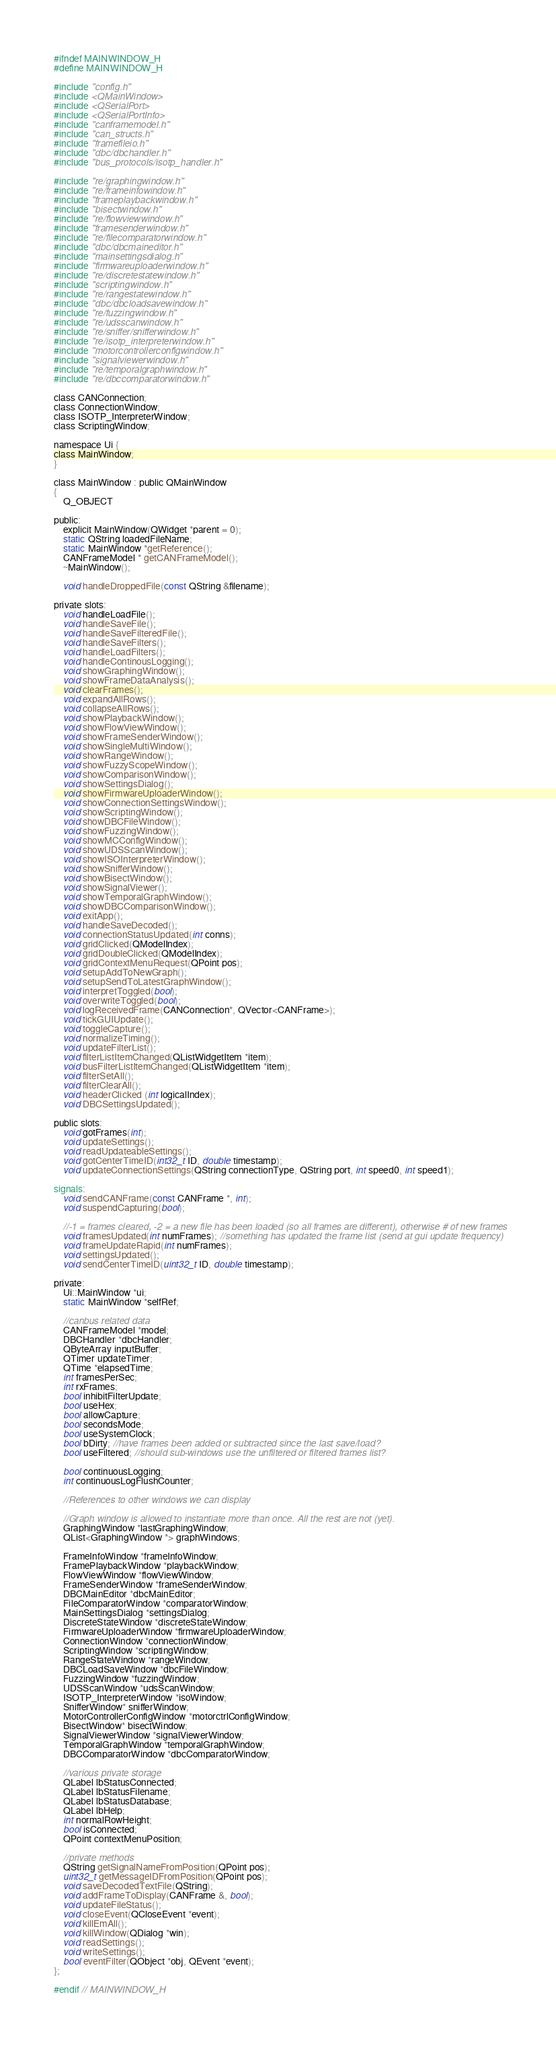<code> <loc_0><loc_0><loc_500><loc_500><_C_>#ifndef MAINWINDOW_H
#define MAINWINDOW_H

#include "config.h"
#include <QMainWindow>
#include <QSerialPort>
#include <QSerialPortInfo>
#include "canframemodel.h"
#include "can_structs.h"
#include "framefileio.h"
#include "dbc/dbchandler.h"
#include "bus_protocols/isotp_handler.h"

#include "re/graphingwindow.h"
#include "re/frameinfowindow.h"
#include "frameplaybackwindow.h"
#include "bisectwindow.h"
#include "re/flowviewwindow.h"
#include "framesenderwindow.h"
#include "re/filecomparatorwindow.h"
#include "dbc/dbcmaineditor.h"
#include "mainsettingsdialog.h"
#include "firmwareuploaderwindow.h"
#include "re/discretestatewindow.h"
#include "scriptingwindow.h"
#include "re/rangestatewindow.h"
#include "dbc/dbcloadsavewindow.h"
#include "re/fuzzingwindow.h"
#include "re/udsscanwindow.h"
#include "re/sniffer/snifferwindow.h"
#include "re/isotp_interpreterwindow.h"
#include "motorcontrollerconfigwindow.h"
#include "signalviewerwindow.h"
#include "re/temporalgraphwindow.h"
#include "re/dbccomparatorwindow.h"

class CANConnection;
class ConnectionWindow;
class ISOTP_InterpreterWindow;
class ScriptingWindow;

namespace Ui {
class MainWindow;
}

class MainWindow : public QMainWindow
{
    Q_OBJECT

public:
    explicit MainWindow(QWidget *parent = 0);
    static QString loadedFileName;
    static MainWindow *getReference();
    CANFrameModel * getCANFrameModel();
    ~MainWindow();

    void handleDroppedFile(const QString &filename);

private slots:
    void handleLoadFile();
    void handleSaveFile();
    void handleSaveFilteredFile();
    void handleSaveFilters();
    void handleLoadFilters();
    void handleContinousLogging();
    void showGraphingWindow();
    void showFrameDataAnalysis();
    void clearFrames();
    void expandAllRows();
    void collapseAllRows();
    void showPlaybackWindow();
    void showFlowViewWindow();
    void showFrameSenderWindow();
    void showSingleMultiWindow();
    void showRangeWindow();
    void showFuzzyScopeWindow();
    void showComparisonWindow();
    void showSettingsDialog();
    void showFirmwareUploaderWindow();
    void showConnectionSettingsWindow();
    void showScriptingWindow();
    void showDBCFileWindow();
    void showFuzzingWindow();
    void showMCConfigWindow();
    void showUDSScanWindow();
    void showISOInterpreterWindow();
    void showSnifferWindow();
    void showBisectWindow();
    void showSignalViewer();
    void showTemporalGraphWindow();
    void showDBCComparisonWindow();
    void exitApp();
    void handleSaveDecoded();
    void connectionStatusUpdated(int conns);
    void gridClicked(QModelIndex);
    void gridDoubleClicked(QModelIndex);
    void gridContextMenuRequest(QPoint pos);
    void setupAddToNewGraph();
    void setupSendToLatestGraphWindow();
    void interpretToggled(bool);
    void overwriteToggled(bool);
    void logReceivedFrame(CANConnection*, QVector<CANFrame>);
    void tickGUIUpdate();
    void toggleCapture();
    void normalizeTiming();
    void updateFilterList();
    void filterListItemChanged(QListWidgetItem *item);
    void busFilterListItemChanged(QListWidgetItem *item);
    void filterSetAll();
    void filterClearAll();
    void headerClicked (int logicalIndex);
    void DBCSettingsUpdated();

public slots:
    void gotFrames(int);
    void updateSettings();
    void readUpdateableSettings();
    void gotCenterTimeID(int32_t ID, double timestamp);
    void updateConnectionSettings(QString connectionType, QString port, int speed0, int speed1);

signals:
    void sendCANFrame(const CANFrame *, int);
    void suspendCapturing(bool);

    //-1 = frames cleared, -2 = a new file has been loaded (so all frames are different), otherwise # of new frames
    void framesUpdated(int numFrames); //something has updated the frame list (send at gui update frequency)
    void frameUpdateRapid(int numFrames);
    void settingsUpdated();
    void sendCenterTimeID(uint32_t ID, double timestamp);

private:
    Ui::MainWindow *ui;
    static MainWindow *selfRef;

    //canbus related data
    CANFrameModel *model;
    DBCHandler *dbcHandler;
    QByteArray inputBuffer;
    QTimer updateTimer;
    QTime *elapsedTime;
    int framesPerSec;
    int rxFrames;
    bool inhibitFilterUpdate;
    bool useHex;
    bool allowCapture;
    bool secondsMode;
    bool useSystemClock;
    bool bDirty; //have frames been added or subtracted since the last save/load?
    bool useFiltered; //should sub-windows use the unfiltered or filtered frames list?

    bool continuousLogging;
    int continuousLogFlushCounter;

    //References to other windows we can display

    //Graph window is allowed to instantiate more than once. All the rest are not (yet).
    GraphingWindow *lastGraphingWindow;
    QList<GraphingWindow *> graphWindows;

    FrameInfoWindow *frameInfoWindow;
    FramePlaybackWindow *playbackWindow;
    FlowViewWindow *flowViewWindow;
    FrameSenderWindow *frameSenderWindow;
    DBCMainEditor *dbcMainEditor;
    FileComparatorWindow *comparatorWindow;
    MainSettingsDialog *settingsDialog;
    DiscreteStateWindow *discreteStateWindow;
    FirmwareUploaderWindow *firmwareUploaderWindow;
    ConnectionWindow *connectionWindow;
    ScriptingWindow *scriptingWindow;
    RangeStateWindow *rangeWindow;
    DBCLoadSaveWindow *dbcFileWindow;
    FuzzingWindow *fuzzingWindow;
    UDSScanWindow *udsScanWindow;
    ISOTP_InterpreterWindow *isoWindow;
    SnifferWindow* snifferWindow;
    MotorControllerConfigWindow *motorctrlConfigWindow;
    BisectWindow* bisectWindow;
    SignalViewerWindow *signalViewerWindow;
    TemporalGraphWindow *temporalGraphWindow;
    DBCComparatorWindow *dbcComparatorWindow;

    //various private storage
    QLabel lbStatusConnected;
    QLabel lbStatusFilename;
    QLabel lbStatusDatabase;
    QLabel lbHelp;
    int normalRowHeight;
    bool isConnected;
    QPoint contextMenuPosition;

    //private methods
    QString getSignalNameFromPosition(QPoint pos);
    uint32_t getMessageIDFromPosition(QPoint pos);
    void saveDecodedTextFile(QString);
    void addFrameToDisplay(CANFrame &, bool);
    void updateFileStatus();
    void closeEvent(QCloseEvent *event);
    void killEmAll();
    void killWindow(QDialog *win);
    void readSettings();
    void writeSettings();
    bool eventFilter(QObject *obj, QEvent *event);
};

#endif // MAINWINDOW_H
</code> 